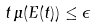<formula> <loc_0><loc_0><loc_500><loc_500>t \, \mu ( E ( t ) ) \leq \epsilon</formula> 